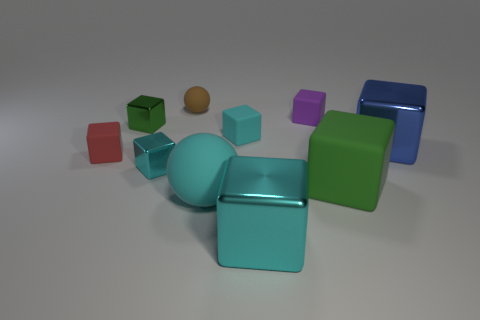Does the small cyan metallic object have the same shape as the small brown thing?
Provide a short and direct response. No. How many small gray matte things are the same shape as the large green matte object?
Your answer should be compact. 0. What material is the brown object that is the same size as the red rubber cube?
Your response must be concise. Rubber. There is a cyan matte object that is on the right side of the sphere in front of the small cyan thing in front of the tiny red rubber thing; how big is it?
Give a very brief answer. Small. Is the color of the big thing left of the small cyan matte cube the same as the big block that is in front of the big matte block?
Your answer should be compact. Yes. What number of cyan things are tiny cubes or big things?
Your answer should be compact. 4. What number of brown rubber balls have the same size as the purple matte object?
Keep it short and to the point. 1. Do the green block to the left of the green rubber block and the red object have the same material?
Provide a short and direct response. No. Is there a small cyan rubber block that is in front of the cyan metallic thing that is in front of the green matte thing?
Give a very brief answer. No. There is a large cyan object that is the same shape as the blue metal thing; what is it made of?
Your answer should be compact. Metal. 